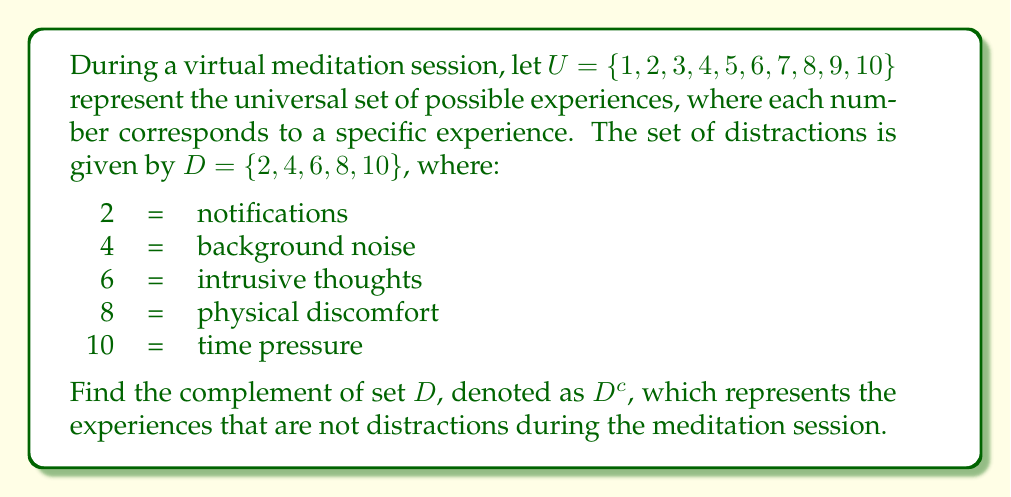Give your solution to this math problem. To find the complement of set $D$, we need to identify all elements in the universal set $U$ that are not in set $D$. 

1) First, let's recall the definition of a complement:
   The complement of a set $A$, denoted $A^c$, is the set of all elements in the universal set $U$ that are not in $A$.

2) Mathematically, we can express this as:
   $$D^c = \{x \in U : x \notin D\}$$

3) Let's identify the elements in $U$ that are not in $D$:
   - 1 is in $U$ but not in $D$
   - 3 is in $U$ but not in $D$
   - 5 is in $U$ but not in $D$
   - 7 is in $U$ but not in $D$
   - 9 is in $U$ but not in $D$

4) Therefore, the complement of $D$ is:
   $$D^c = \{1, 3, 5, 7, 9\}$$

These elements represent the experiences during meditation that are not distractions, which could be interpreted as:
1 = focused breathing
3 = body awareness
5 = sense of calm
7 = clarity of mind 
9 = feeling of presence
Answer: $D^c = \{1, 3, 5, 7, 9\}$ 